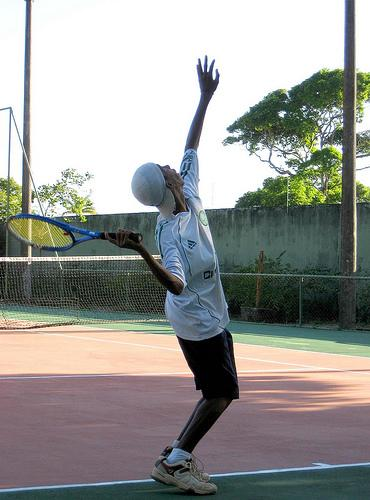Explain the main subject of the image and their current activity. The main subject is a man playing tennis, wearing a white hat and black shorts, and is about to hit the ball. Write a sentence highlighting the tennis player's clothing in the image. The man on the tennis court is wearing a white hat, white shirt, black shorts, and black, tan, and red sneakers. Briefly describe what the tennis player is about to do in the image. The tennis player is preparing to serve the ball as he throws it into the air. Describe the scene in the image in the context of a tennis match. A tennis player, dressed in a white hat, white shirt, and black shorts, is on the court, about to serve the ball. Provide a short description of the image focusing on the main action taking place. Tennis player on the court, wearing a white hat and black shorts, about to hit a ball thrown in the air. Mention a few items present in the image that draw attention. A tennis player with a blue racquet, a white net on the court, and a tall tree behind the concrete wall. Write a concise description of the image focusing on the man's actions and surroundings. A man playing tennis, raising his arm to hit the ball, with a white net, fence, and tree in the background. Summarize the scene shown in the image. A man playing tennis on a red court, wearing a hat, white shirt, and black shorts, prepares to hit the ball as it's thrown in the air. Describe the tennis court environment in the image. The tennis court has a white net, red surface, a concrete wall on one side, and is surrounded by a metal chain-link fence with trees in the background. Provide a one-sentence summary of the image, focusing on the player's outfit and action. A tennis player in a white hat, white shirt, and black shorts is preparing to hit the ball in the air on the court. 